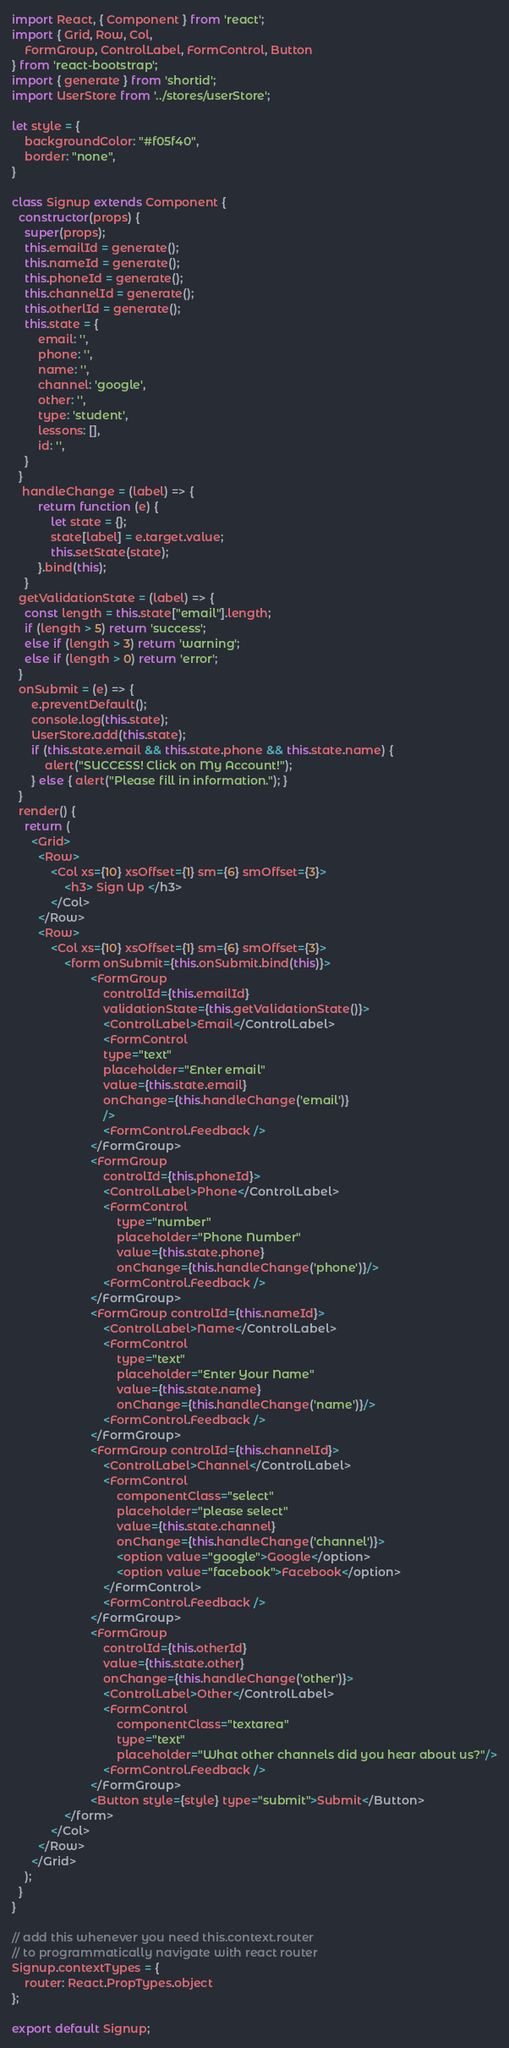<code> <loc_0><loc_0><loc_500><loc_500><_JavaScript_>import React, { Component } from 'react';
import { Grid, Row, Col, 
    FormGroup, ControlLabel, FormControl, Button 
} from 'react-bootstrap';
import { generate } from 'shortid';
import UserStore from '../stores/userStore';

let style = {
    backgroundColor: "#f05f40",
    border: "none",
}

class Signup extends Component {
  constructor(props) {
    super(props);
    this.emailId = generate();
    this.nameId = generate();
    this.phoneId = generate();
    this.channelId = generate();
    this.otherlId = generate();
    this.state = {
        email: '',
        phone: '',
        name: '',
        channel: 'google',
        other: '',
		type: 'student',
		lessons: [],
		id: '',
    }
  }
   handleChange = (label) => {
        return function (e) {
            let state = {};
            state[label] = e.target.value;
            this.setState(state);
        }.bind(this);
    }
  getValidationState = (label) => {
    const length = this.state["email"].length;
    if (length > 5) return 'success';
    else if (length > 3) return 'warning';
    else if (length > 0) return 'error';
  }
  onSubmit = (e) => {
      e.preventDefault();
	  console.log(this.state);
      UserStore.add(this.state);
      if (this.state.email && this.state.phone && this.state.name) {
          alert("SUCCESS! Click on My Account!");
      } else { alert("Please fill in information."); }
  }
  render() {
    return (
      <Grid>
        <Row>
            <Col xs={10} xsOffset={1} sm={6} smOffset={3}>
                <h3> Sign Up </h3>
            </Col>
        </Row>
        <Row>
            <Col xs={10} xsOffset={1} sm={6} smOffset={3}>
                <form onSubmit={this.onSubmit.bind(this)}>
                        <FormGroup 
                            controlId={this.emailId} 
                            validationState={this.getValidationState()}>
                            <ControlLabel>Email</ControlLabel>
                            <FormControl
                            type="text"
                            placeholder="Enter email"
                            value={this.state.email}
                            onChange={this.handleChange('email')}
                            />
                            <FormControl.Feedback />
                        </FormGroup>
                        <FormGroup 
                            controlId={this.phoneId}>
                            <ControlLabel>Phone</ControlLabel>
                            <FormControl
                                type="number"
                                placeholder="Phone Number"
                                value={this.state.phone}
                                onChange={this.handleChange('phone')}/>
                            <FormControl.Feedback />
                        </FormGroup>
                        <FormGroup controlId={this.nameId}>
                            <ControlLabel>Name</ControlLabel>
                            <FormControl
                                type="text"
                                placeholder="Enter Your Name"
                                value={this.state.name}
                                onChange={this.handleChange('name')}/>
                            <FormControl.Feedback />
                        </FormGroup>
                        <FormGroup controlId={this.channelId}>
                            <ControlLabel>Channel</ControlLabel>
                            <FormControl 
                                componentClass="select"
                                placeholder="please select"
                                value={this.state.channel}
                                onChange={this.handleChange('channel')}>
                                <option value="google">Google</option>
                                <option value="facebook">Facebook</option>
                            </FormControl>
                            <FormControl.Feedback />
                        </FormGroup>
                        <FormGroup 
                            controlId={this.otherId}
                            value={this.state.other}
                            onChange={this.handleChange('other')}>
                            <ControlLabel>Other</ControlLabel>
                            <FormControl
                                componentClass="textarea"
                                type="text"
                                placeholder="What other channels did you hear about us?"/>
                            <FormControl.Feedback />
                        </FormGroup>
                        <Button style={style} type="submit">Submit</Button>
                </form>
            </Col>
        </Row>
      </Grid>
    );
  }
}

// add this whenever you need this.context.router
// to programmatically navigate with react router
Signup.contextTypes = {
    router: React.PropTypes.object
};

export default Signup;
</code> 